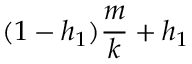Convert formula to latex. <formula><loc_0><loc_0><loc_500><loc_500>( 1 - h _ { 1 } ) \frac { m } { k } + h _ { 1 }</formula> 